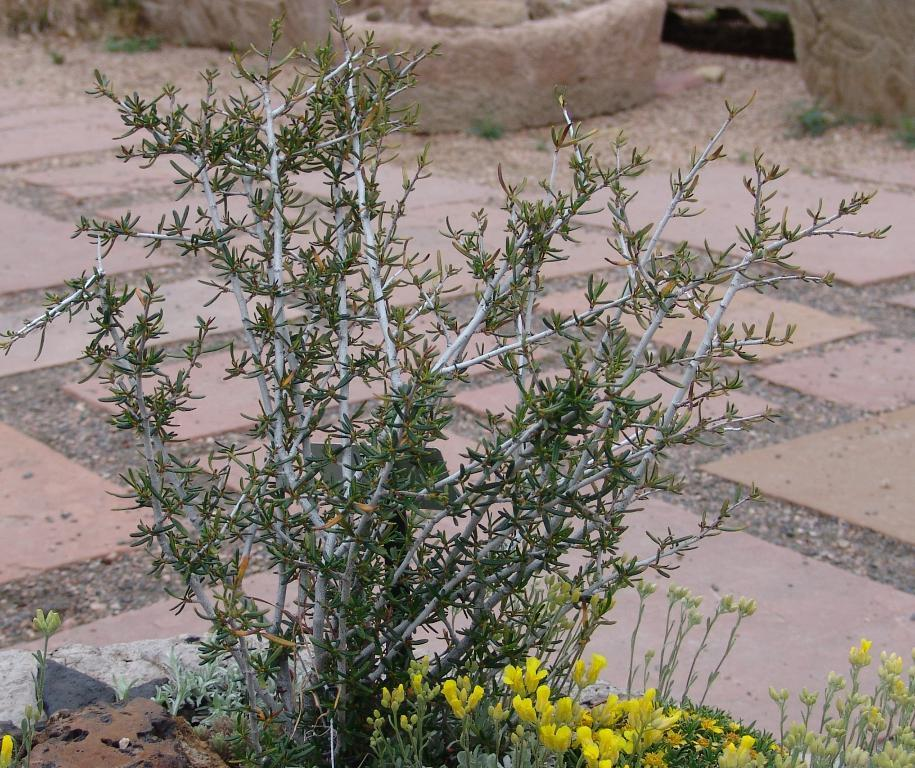What type of living organisms can be seen in the image? Plants can be seen in the image. Are there any specific flowers visible among the plants? Yes, there are yellow flowers in the image. What can be seen in the background of the image? There is a path visible in the background of the image. What is the color of the objects in the image? The objects in the image are light brown. What type of ornament is hanging from the tree in the image? There is no ornament hanging from a tree in the image; it only features plants, yellow flowers, a path, and light brown objects. 